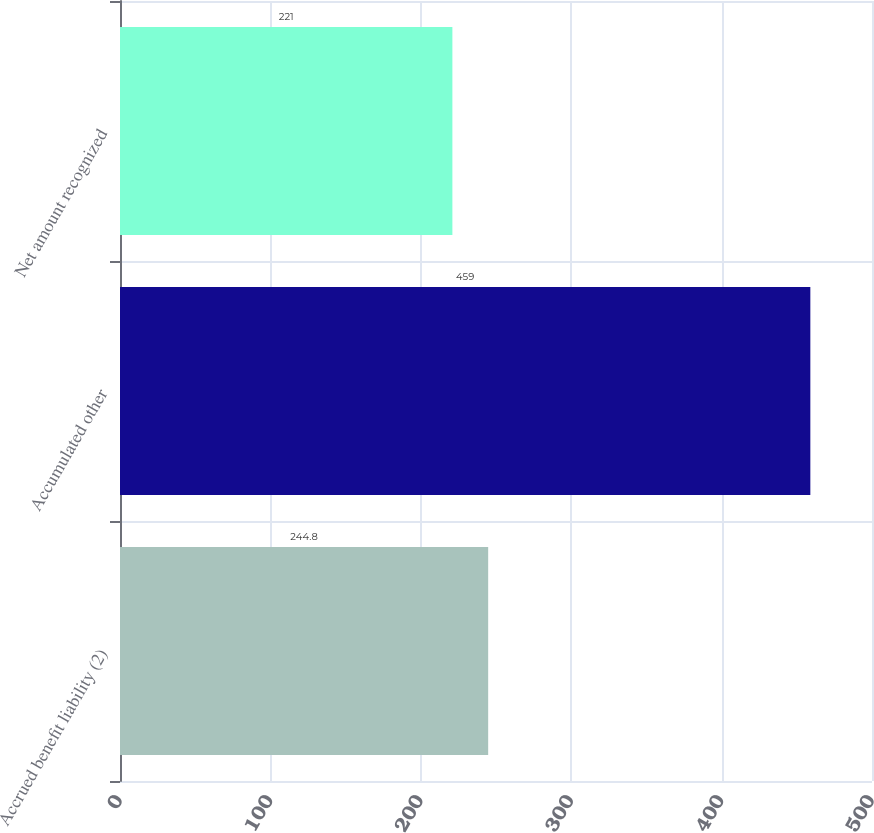<chart> <loc_0><loc_0><loc_500><loc_500><bar_chart><fcel>Accrued benefit liability (2)<fcel>Accumulated other<fcel>Net amount recognized<nl><fcel>244.8<fcel>459<fcel>221<nl></chart> 